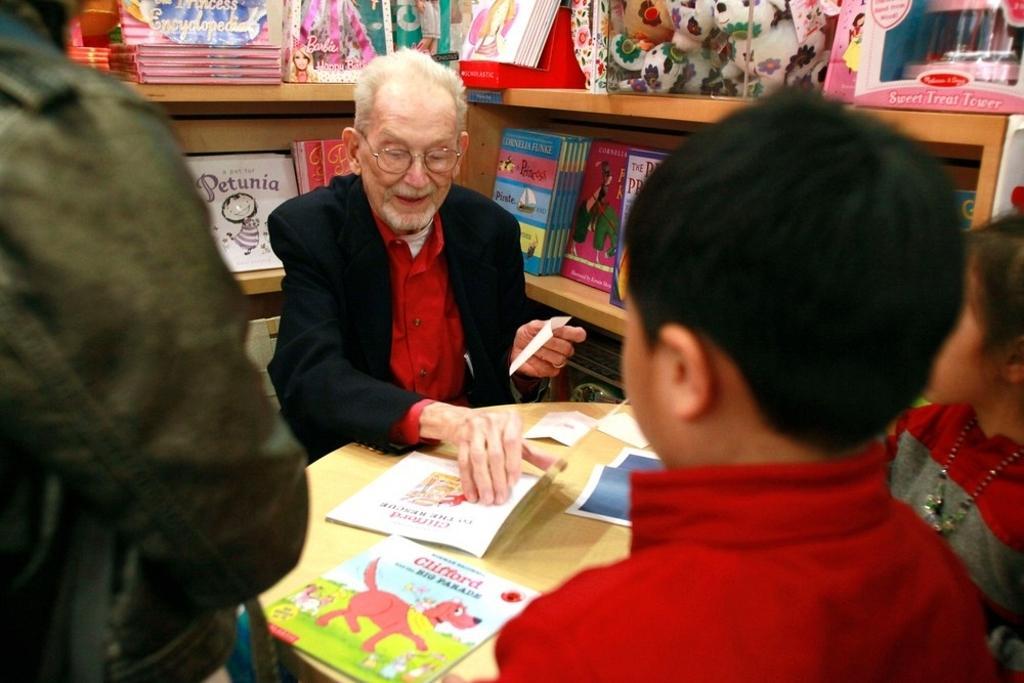Can you describe this image briefly? In this picture I can see three persons, a man sitting , there are papers on the table, a man holding a paper, and in the background there are books and toys in the racks. 